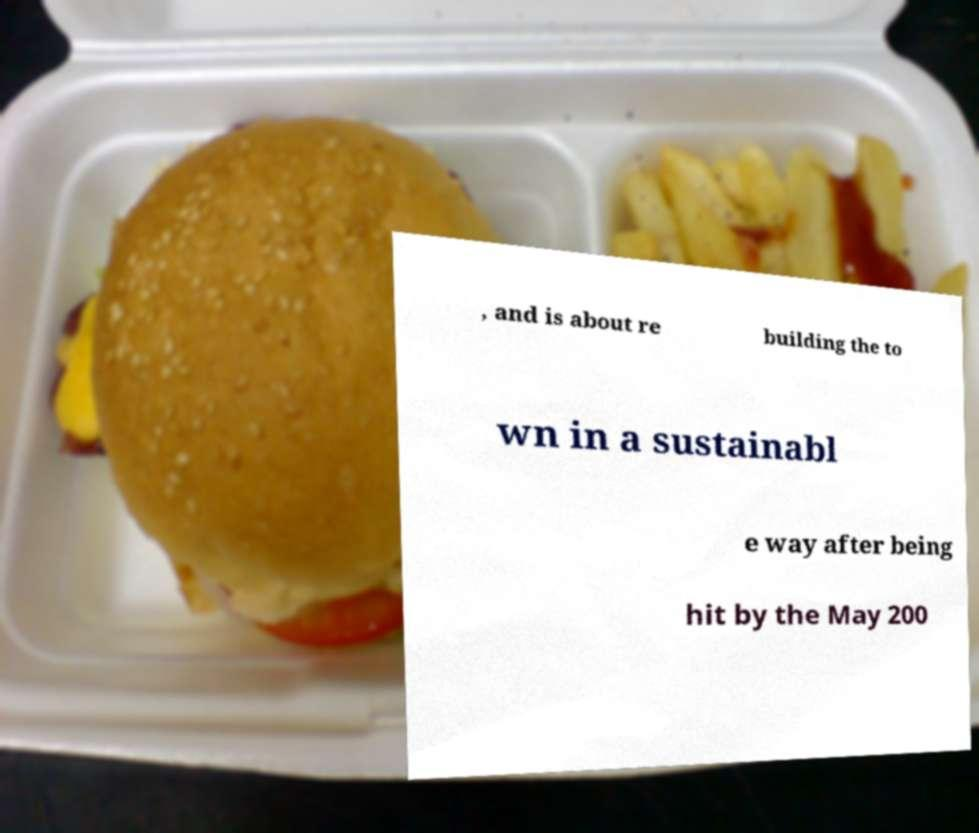Please identify and transcribe the text found in this image. , and is about re building the to wn in a sustainabl e way after being hit by the May 200 